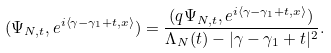Convert formula to latex. <formula><loc_0><loc_0><loc_500><loc_500>( \Psi _ { N , t } , e ^ { i \left \langle \gamma - \gamma _ { 1 } + t , x \right \rangle } ) = \frac { ( q \Psi _ { N , t } , e ^ { i \left \langle \gamma - \gamma _ { 1 } + t , x \right \rangle } ) } { \Lambda _ { N } ( t ) - | \gamma - \gamma _ { 1 } + t | ^ { 2 } } .</formula> 